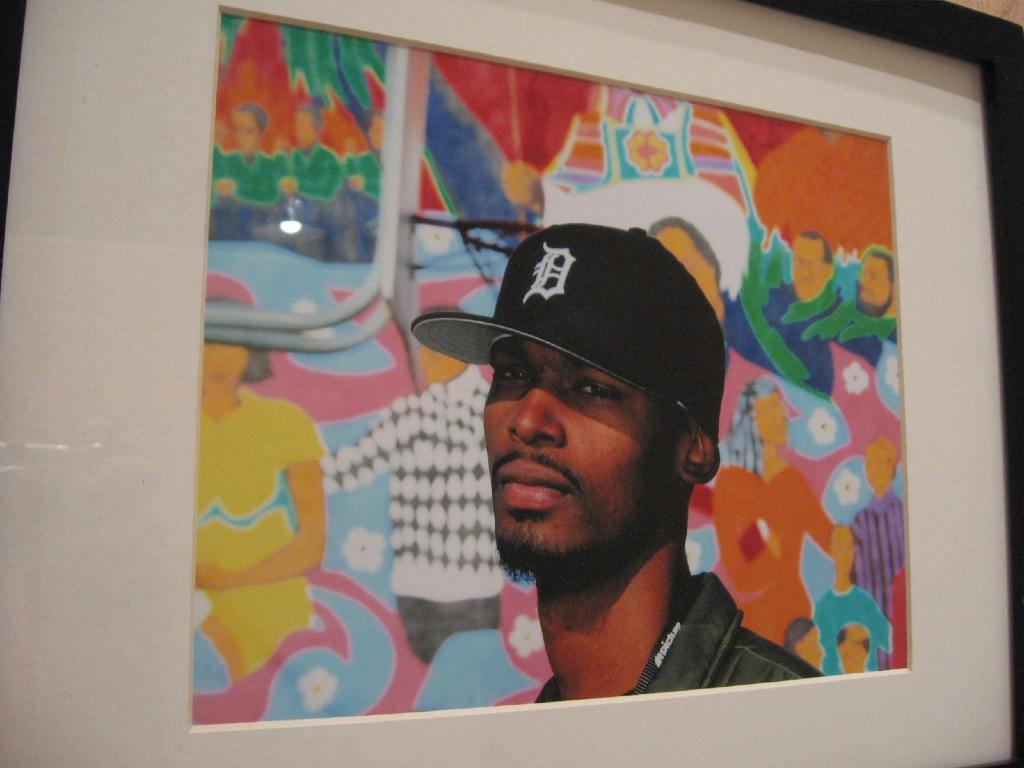What object is located in the foreground area of the image? There is a photo frame in the foreground area of the image. What type of birth is depicted in the photo frame? There is no information about a photo or any content within the photo frame, so it is not possible to determine if a birth is depicted. 